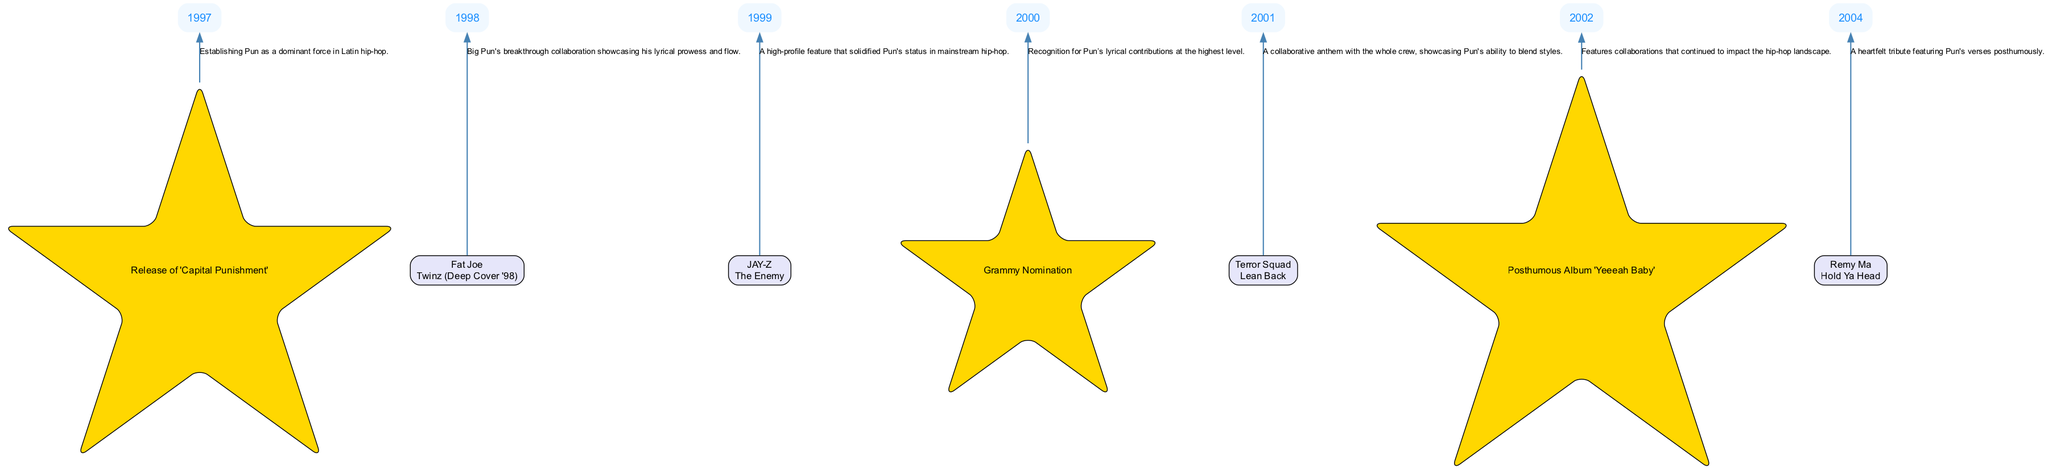What artist collaborated with Big Pun in 1998? The diagram indicates that Fat Joe collaborated with Big Pun in 1998, as shown under the collaboration node labeled "Fat Joe" with the song "Twinz (Deep Cover '98)."
Answer: Fat Joe How many collaborations are listed in the diagram? By counting each collaboration node in the diagram, there are a total of four collaborations listed: Fat Joe, JAY-Z, Terror Squad, and Remy Ma.
Answer: 4 Which year marks the release of Big Pun's album "Capital Punishment"? The milestone node labeled "Release of 'Capital Punishment'" is connected to the year 1997, indicating that this event took place in that year.
Answer: 1997 What song did Big Pun collaborate on with JAY-Z? The collaboration node for JAY-Z clearly states the song "The Enemy," which is the song they worked on together.
Answer: The Enemy Which event in 2000 recognizes Big Pun's lyrical contributions? The milestone labeled "Grammy Nomination" in the year 2000 points to his recognition at the highest level for his lyrical contributions.
Answer: Grammy Nomination What genre does the diagram primarily focus on? The collaborations and milestones revolve around hip-hop, especially emphasizing Big Pun’s contributions to Latin hip-hop showcased in the diagram.
Answer: Hip-hop In what year did Big Pun feature on "Lean Back" with Terror Squad? The collaboration node for Terror Squad indicates that the song "Lean Back" was released in 2001, reflected in the edge connecting them.
Answer: 2001 What type of nodes represent the key milestones in the diagram? The key milestones are represented as star-shaped nodes in the diagram, distinguishing them from collaboration nodes, which are box-shaped.
Answer: Star-shaped What is the significance of the year 2002 in the context of Big Pun's music? The year 2002 is significant as it marks the release of the posthumous album "Yeeeah Baby," which is indicated in the diagram under the key milestones.
Answer: Posthumous Album 'Yeeeah Baby' 